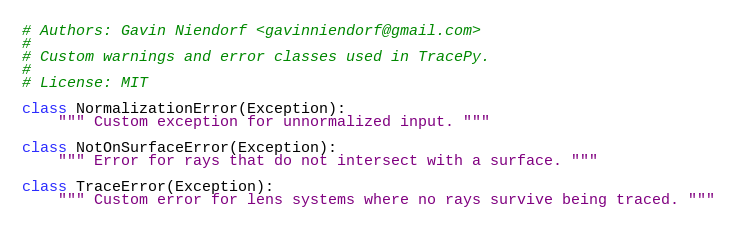<code> <loc_0><loc_0><loc_500><loc_500><_Python_># Authors: Gavin Niendorf <gavinniendorf@gmail.com>
#
# Custom warnings and error classes used in TracePy.
#
# License: MIT

class NormalizationError(Exception):
    """ Custom exception for unnormalized input. """

class NotOnSurfaceError(Exception):
    """ Error for rays that do not intersect with a surface. """

class TraceError(Exception):
    """ Custom error for lens systems where no rays survive being traced. """
</code> 